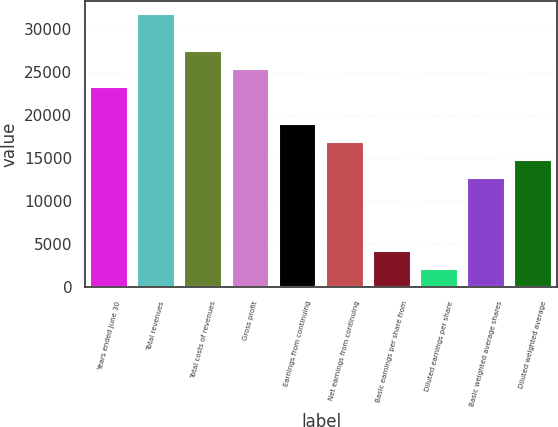<chart> <loc_0><loc_0><loc_500><loc_500><bar_chart><fcel>Years ended June 30<fcel>Total revenues<fcel>Total costs of revenues<fcel>Gross profit<fcel>Earnings from continuing<fcel>Net earnings from continuing<fcel>Basic earnings per share from<fcel>Diluted earnings per share<fcel>Basic weighted average shares<fcel>Diluted weighted average<nl><fcel>23232.7<fcel>31680.7<fcel>27456.7<fcel>25344.7<fcel>19008.6<fcel>16896.6<fcel>4224.56<fcel>2112.55<fcel>12672.6<fcel>14784.6<nl></chart> 